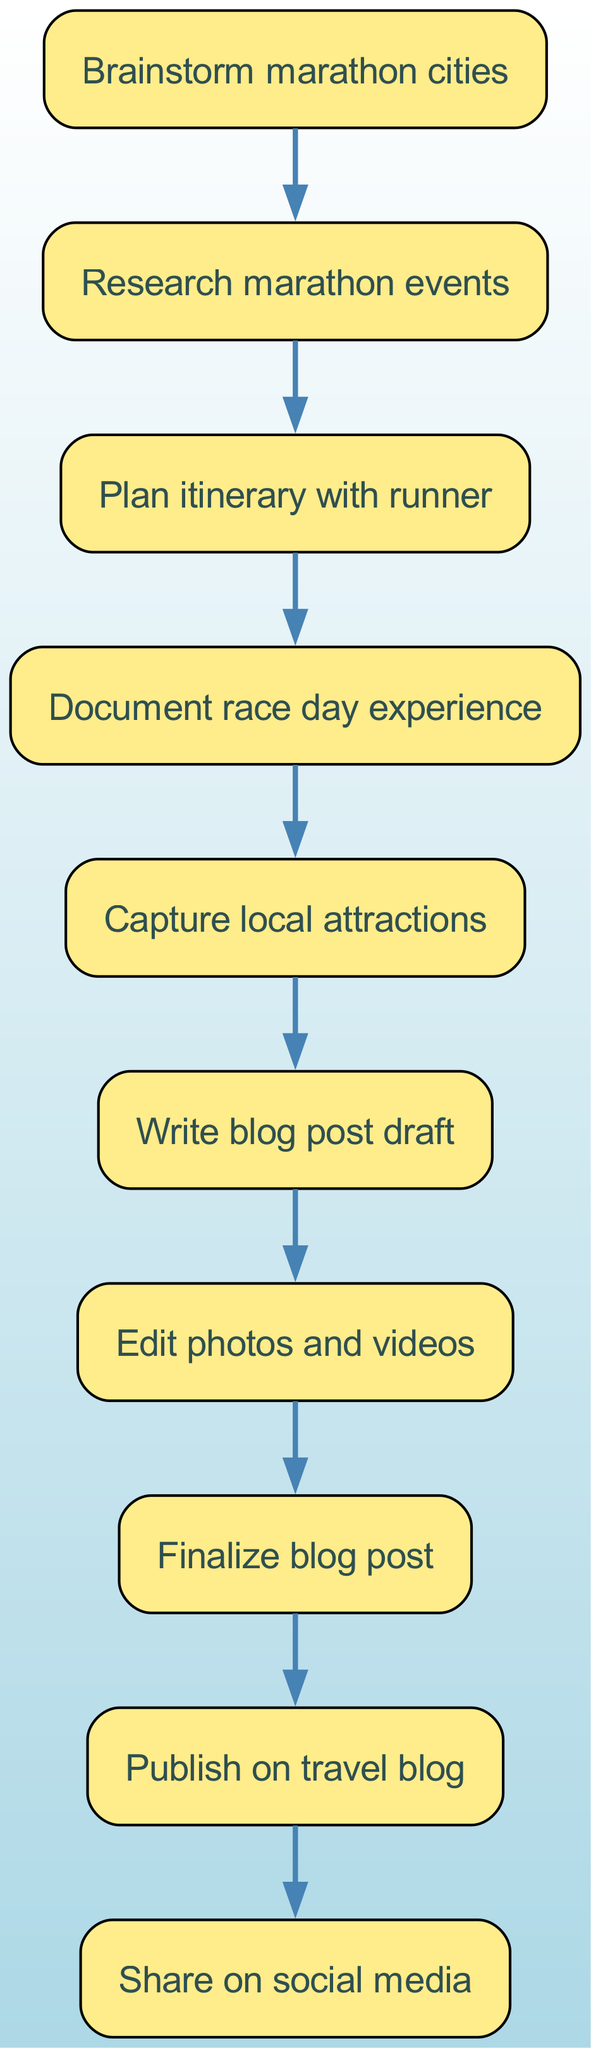What is the first step in the workflow? The first step in the workflow is indicated by the first node in the diagram, which is "Brainstorm marathon cities."
Answer: Brainstorm marathon cities How many nodes are there in the diagram? By counting the number of distinct steps or processes represented in the diagram, there are a total of 10 nodes.
Answer: 10 What is the last action to be completed in the workflow? The last action indicated in the diagram is represented by the last node, which states "Share on social media."
Answer: Share on social media Which two steps come before writing the blog post draft? To find the two steps that precede "Write blog post draft," we look for the previous nodes, which are "Capture local attractions" and "Document race day experience."
Answer: Capture local attractions, Document race day experience What is the relationship between "Research marathon events" and "Plan itinerary with runner"? "Research marathon events" leads directly to "Plan itinerary with runner," indicating that researching is a prerequisite for planning the itinerary.
Answer: Leads directly to Which step immediately follows "Finalize blog post"? To determine the step that immediately follows "Finalize blog post," we refer to the diagram and find that the subsequent step is "Publish on travel blog."
Answer: Publish on travel blog What are the two consecutive actions after documenting the race day experience? Looking at the diagram, the two consecutive actions after "Document race day experience" are "Capture local attractions" followed by "Write blog post draft."
Answer: Capture local attractions, Write blog post draft What is the common goal of the entire workflow illustrated in the diagram? The common goal of this workflow is to successfully create and publish a travel blog post, which can be inferred from the sequence of steps involved in the process.
Answer: Create and publish a travel blog post How does "Edit photos and videos" contribute to the final output of the workflow? "Edit photos and videos" is a crucial step that enhances the quality of the content being published, ensuring that the visuals in the blog post are engaging and professional.
Answer: Enhances the quality of the content 